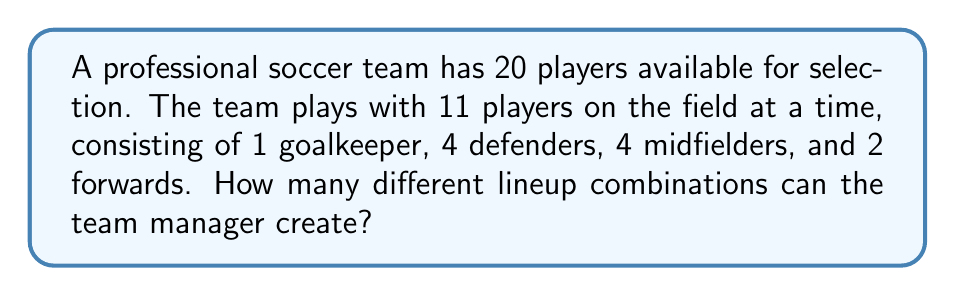Teach me how to tackle this problem. Let's break this down step-by-step:

1. First, we need to choose 1 goalkeeper out of the 20 players:
   $${20 \choose 1} = 20$$

2. After selecting the goalkeeper, we have 19 players left to fill the remaining positions.

3. Next, we need to choose 4 defenders out of the remaining 19 players:
   $${19 \choose 4} = 3876$$

4. After selecting the defenders, we have 15 players left.

5. Now, we need to choose 4 midfielders out of the remaining 15 players:
   $${15 \choose 4} = 1365$$

6. After selecting the midfielders, we have 11 players left.

7. Finally, we need to choose 2 forwards out of the remaining 11 players:
   $${11 \choose 2} = 55$$

8. According to the multiplication principle, the total number of possible lineup combinations is the product of all these individual choices:

   $$20 \times 3876 \times 1365 \times 55 = 5,748,019,200$$

Therefore, the team manager can create 5,748,019,200 different lineup combinations.
Answer: 5,748,019,200 